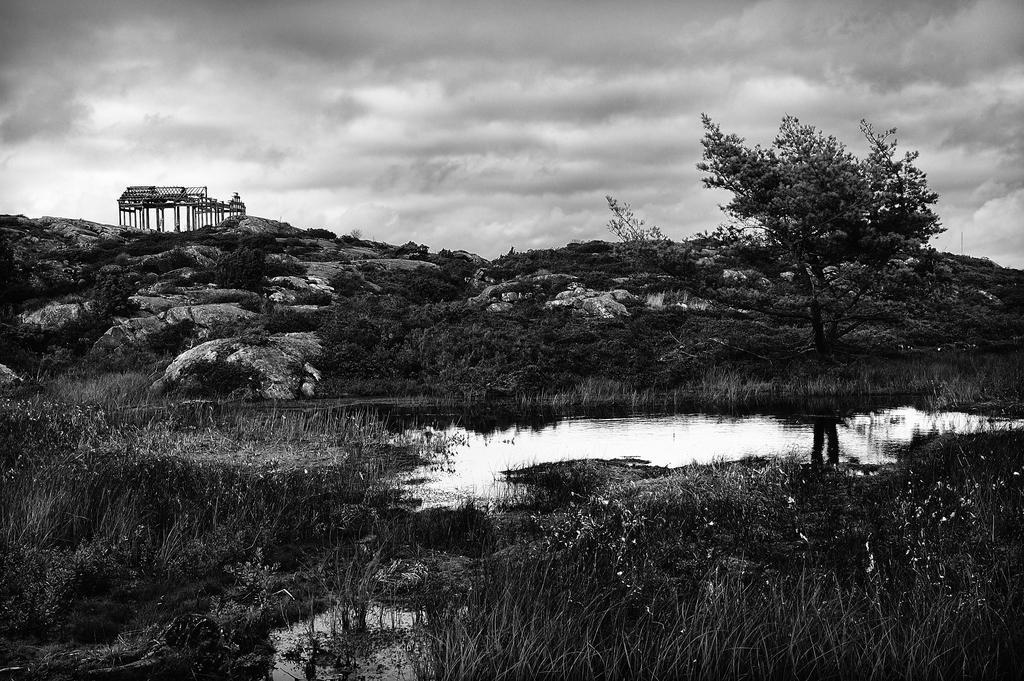In one or two sentences, can you explain what this image depicts? In the background we can see the sky arch with wooden poles. In this picture we can see the rocks and the thicket. We can see the plants, water and the grass. On the right side of the picture we can see a tree. 